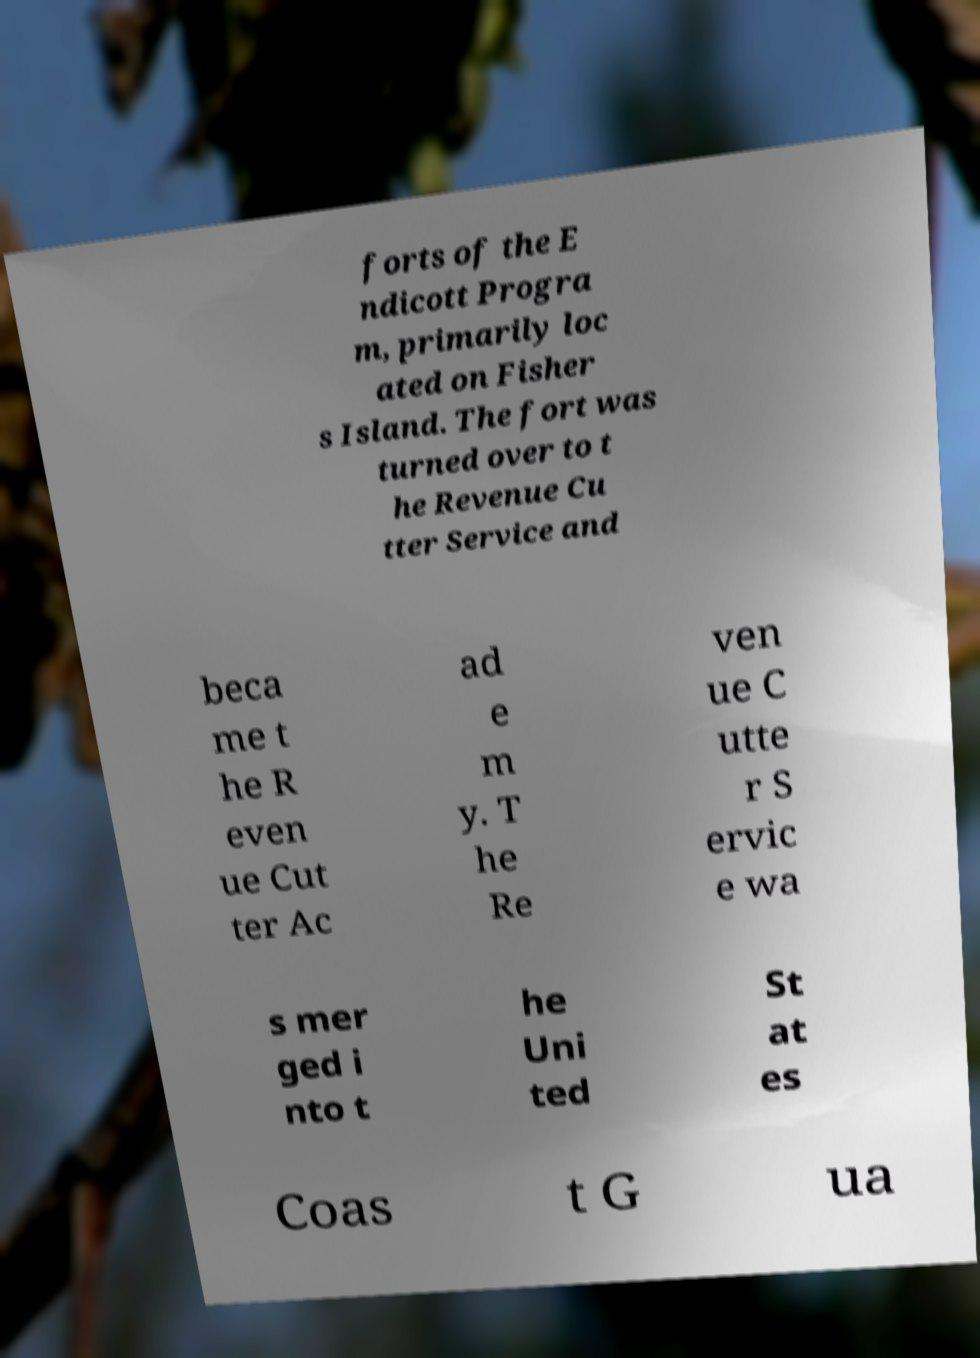Could you extract and type out the text from this image? forts of the E ndicott Progra m, primarily loc ated on Fisher s Island. The fort was turned over to t he Revenue Cu tter Service and beca me t he R even ue Cut ter Ac ad e m y. T he Re ven ue C utte r S ervic e wa s mer ged i nto t he Uni ted St at es Coas t G ua 